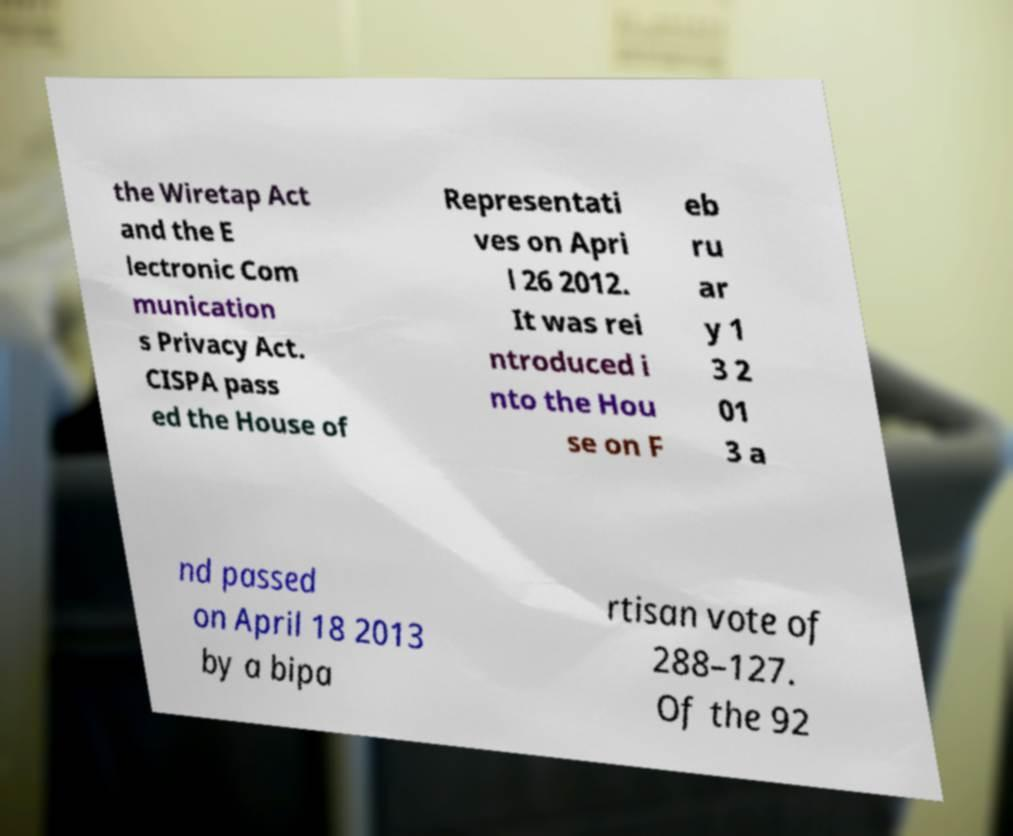Please read and relay the text visible in this image. What does it say? the Wiretap Act and the E lectronic Com munication s Privacy Act. CISPA pass ed the House of Representati ves on Apri l 26 2012. It was rei ntroduced i nto the Hou se on F eb ru ar y 1 3 2 01 3 a nd passed on April 18 2013 by a bipa rtisan vote of 288–127. Of the 92 